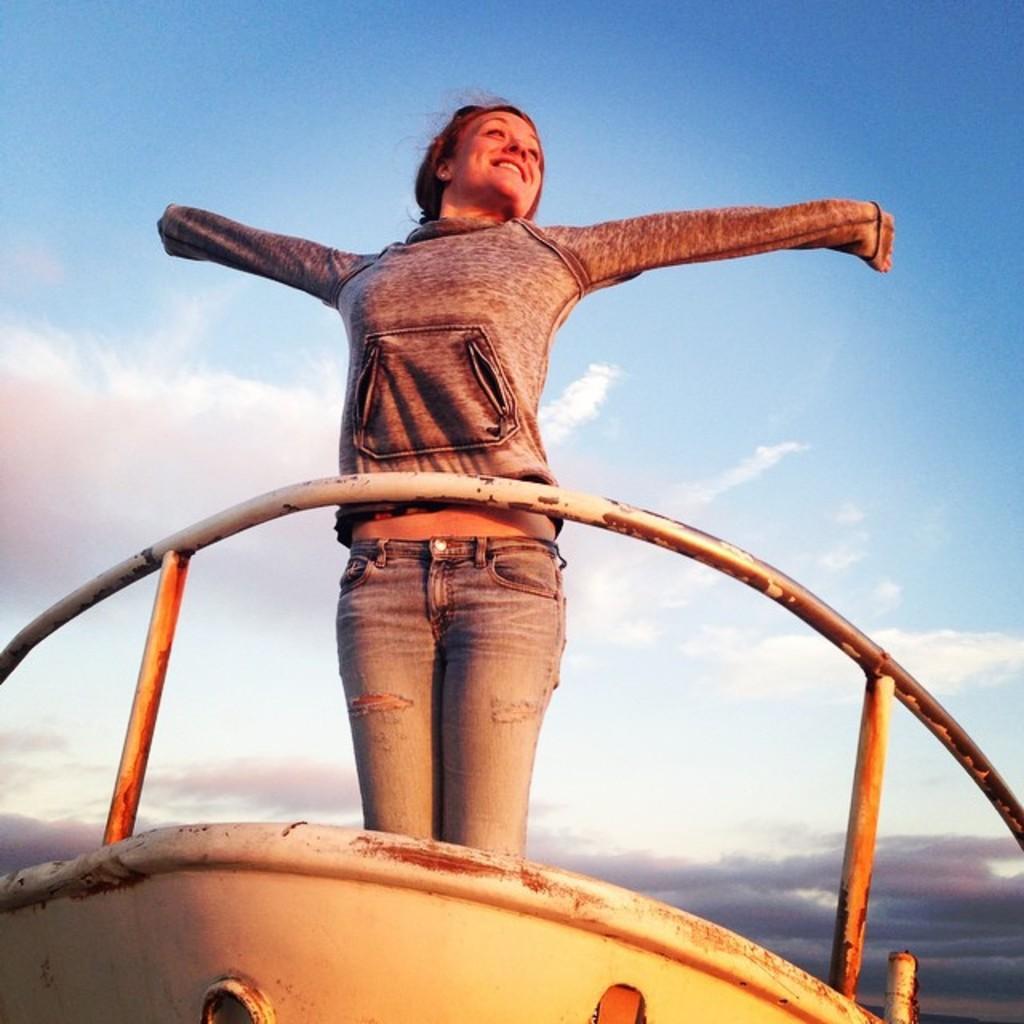How would you summarize this image in a sentence or two? In this picture we can see a boat in the front, there is a woman standing in the boat, we can see the sky and clouds in the background. 